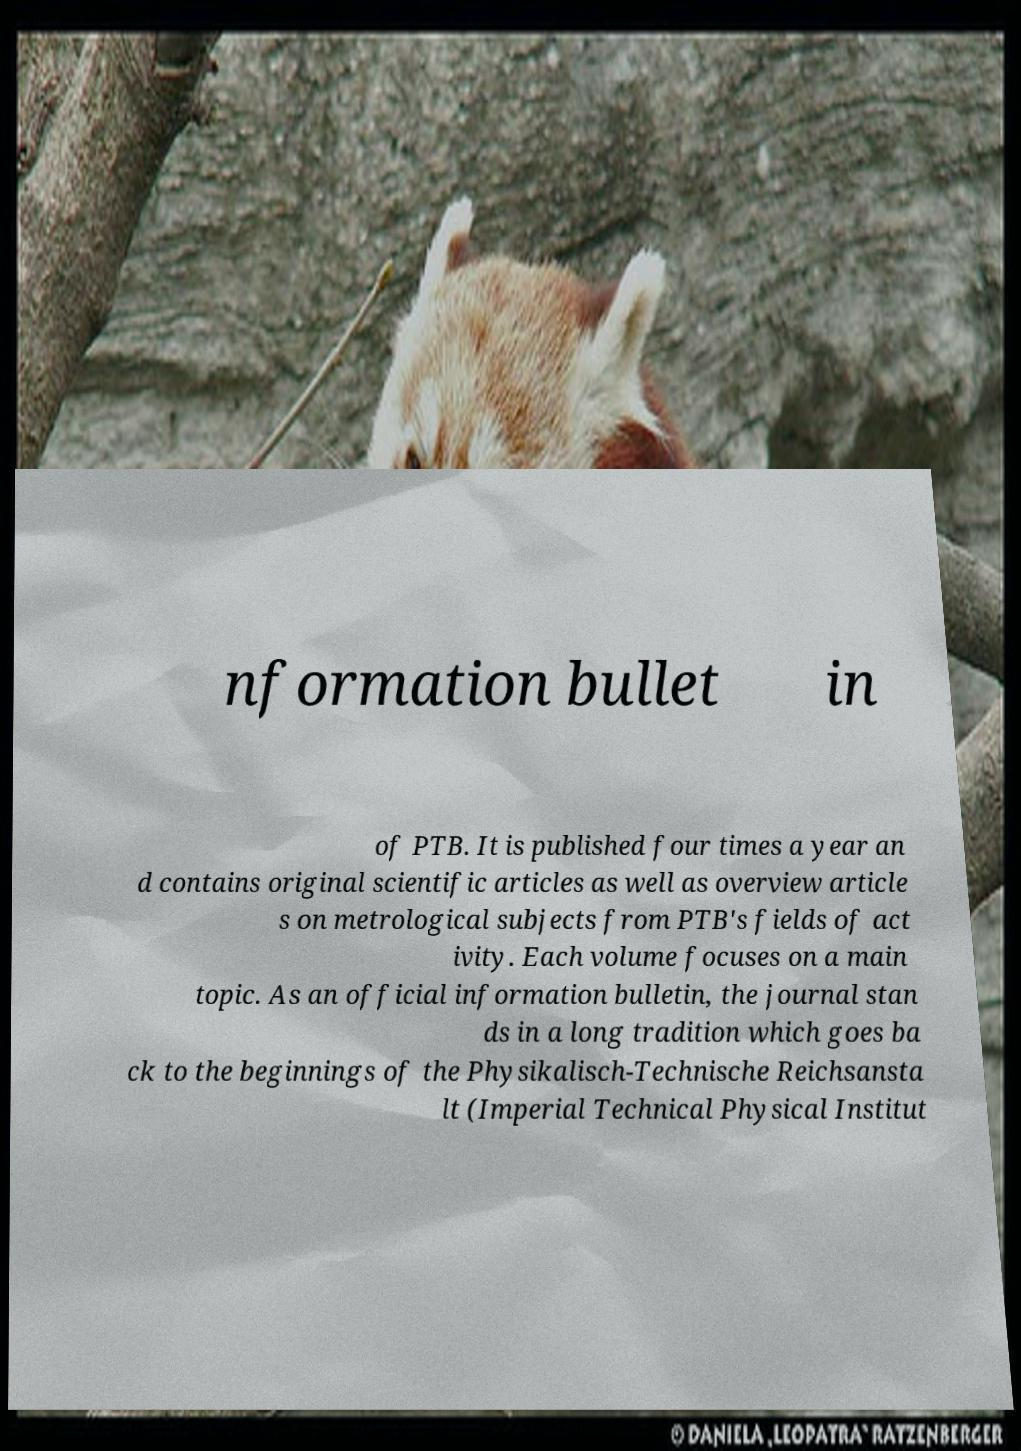Please read and relay the text visible in this image. What does it say? nformation bullet in of PTB. It is published four times a year an d contains original scientific articles as well as overview article s on metrological subjects from PTB's fields of act ivity. Each volume focuses on a main topic. As an official information bulletin, the journal stan ds in a long tradition which goes ba ck to the beginnings of the Physikalisch-Technische Reichsansta lt (Imperial Technical Physical Institut 